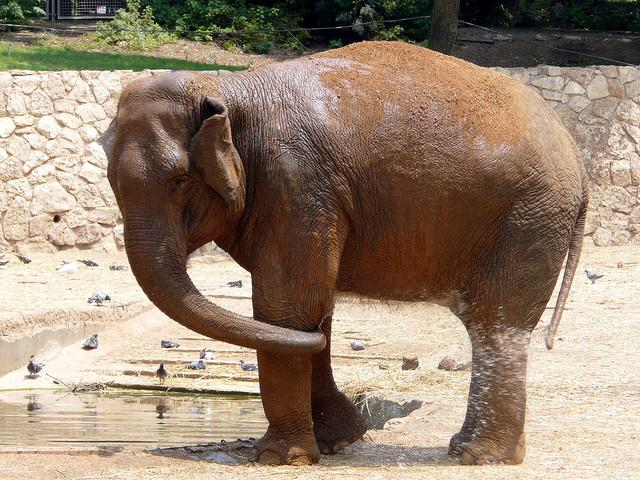Why do hunters hunt this animal?

Choices:
A) ears
B) trunk
C) ivory tusks
D) tail ivory tusks 